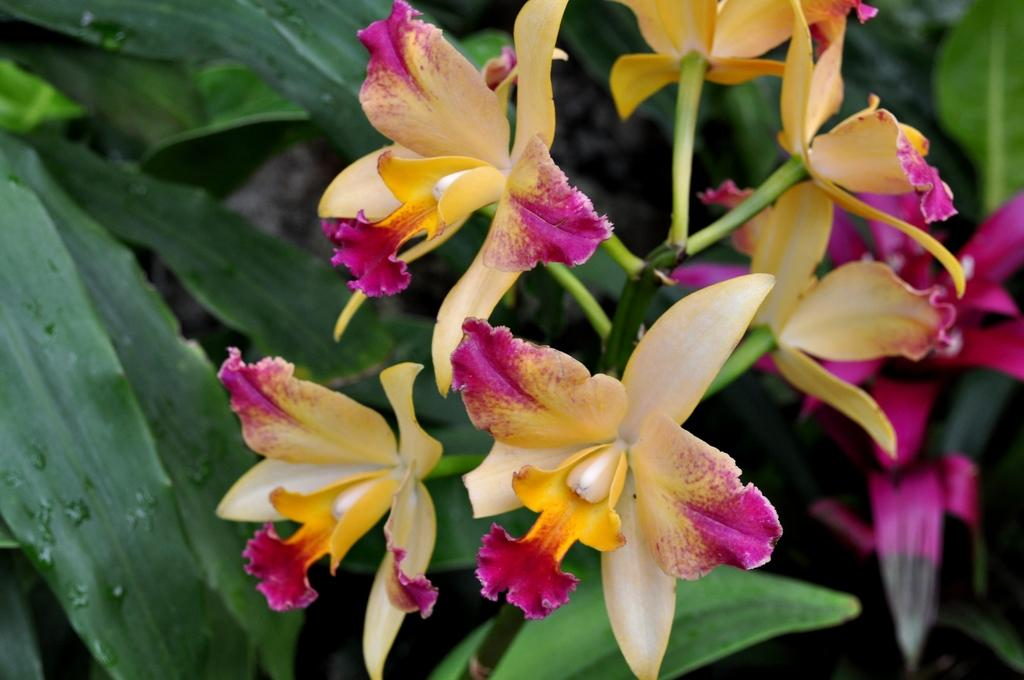What colors are the flowers on the stem in the image? There are pink and yellow flowers on the stem in the image. Are the pink and yellow flowers on separate stems or the same stem? The pink and yellow flowers are on the same stem in the image. What else can be seen in the background of the image? There are leaves visible in the background. What type of pancake is being served with the news in the image? There is no pancake or news present in the image; it features flowers on a stem with leaves in the background. 